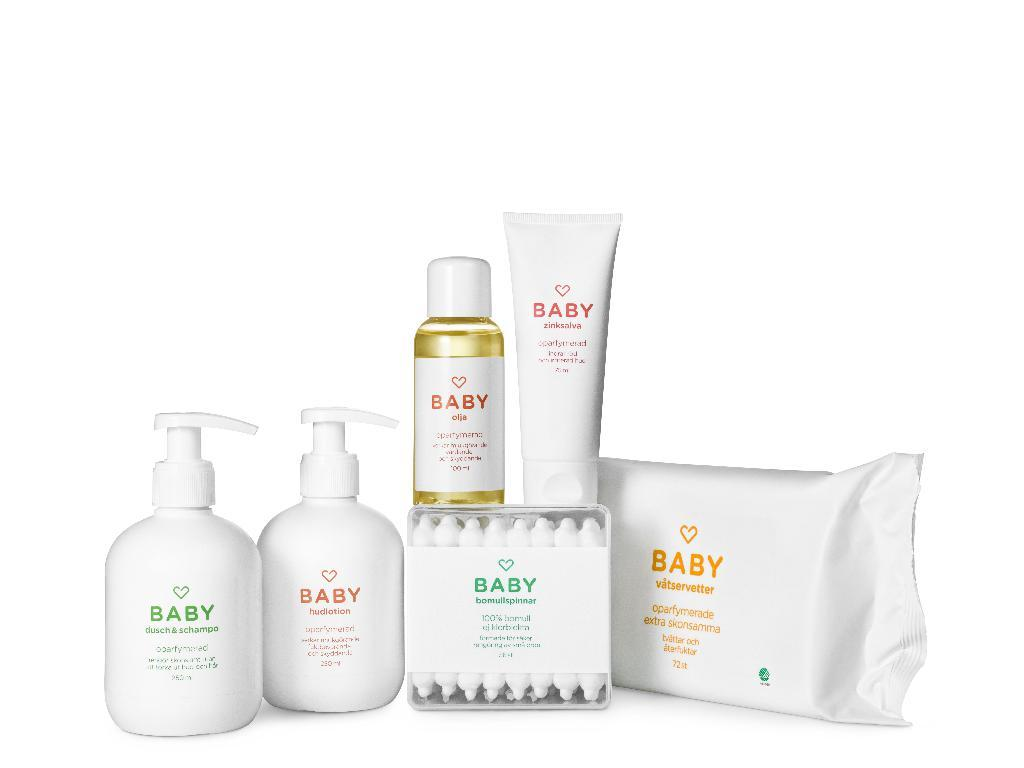<image>
Offer a succinct explanation of the picture presented. Various baby products such as shampoo and lotion 